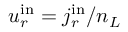Convert formula to latex. <formula><loc_0><loc_0><loc_500><loc_500>{ u _ { r } ^ { i n } = j _ { r } ^ { i n } / n _ { L } }</formula> 